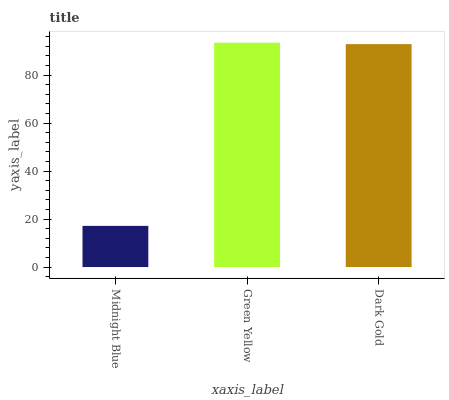Is Midnight Blue the minimum?
Answer yes or no. Yes. Is Green Yellow the maximum?
Answer yes or no. Yes. Is Dark Gold the minimum?
Answer yes or no. No. Is Dark Gold the maximum?
Answer yes or no. No. Is Green Yellow greater than Dark Gold?
Answer yes or no. Yes. Is Dark Gold less than Green Yellow?
Answer yes or no. Yes. Is Dark Gold greater than Green Yellow?
Answer yes or no. No. Is Green Yellow less than Dark Gold?
Answer yes or no. No. Is Dark Gold the high median?
Answer yes or no. Yes. Is Dark Gold the low median?
Answer yes or no. Yes. Is Midnight Blue the high median?
Answer yes or no. No. Is Midnight Blue the low median?
Answer yes or no. No. 